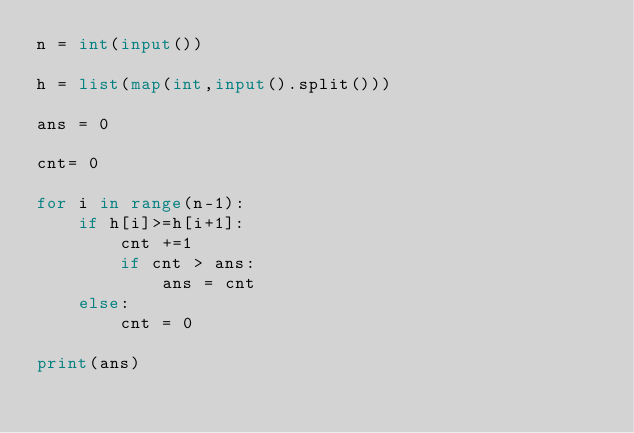<code> <loc_0><loc_0><loc_500><loc_500><_Python_>n = int(input())

h = list(map(int,input().split()))

ans = 0

cnt= 0

for i in range(n-1):
    if h[i]>=h[i+1]:
        cnt +=1
        if cnt > ans:
            ans = cnt
    else:
        cnt = 0
            
print(ans)</code> 